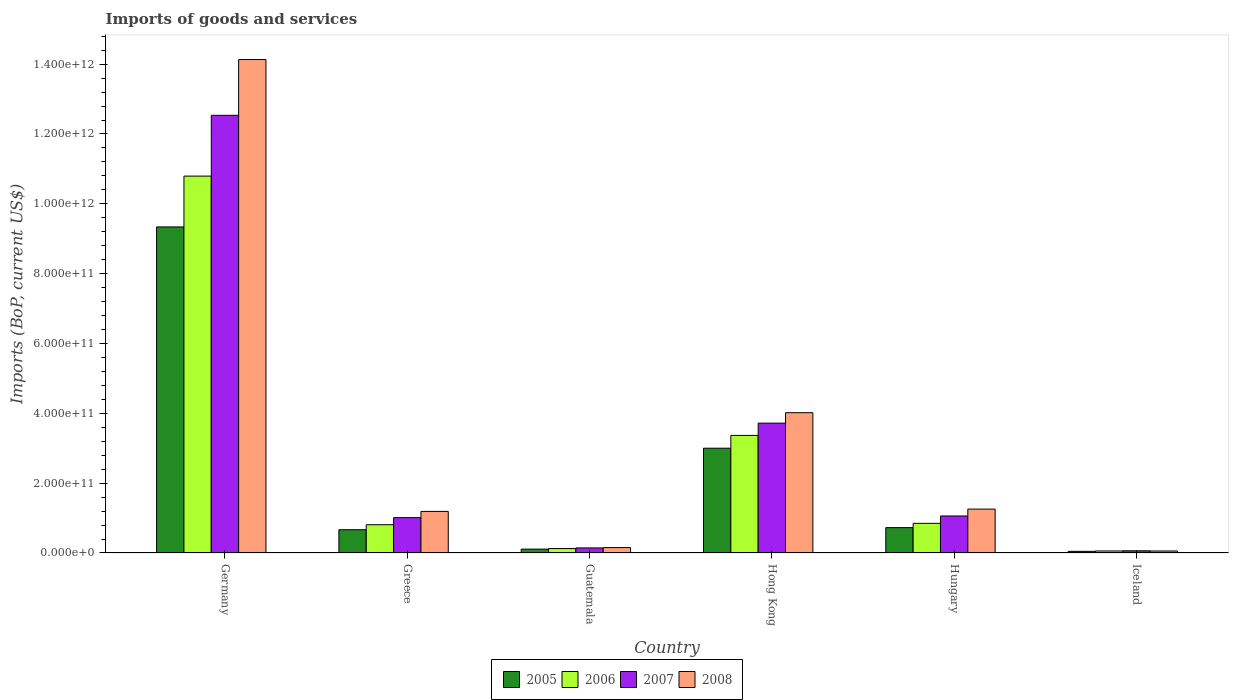How many different coloured bars are there?
Ensure brevity in your answer.  4. Are the number of bars per tick equal to the number of legend labels?
Make the answer very short. Yes. What is the label of the 5th group of bars from the left?
Provide a succinct answer. Hungary. In how many cases, is the number of bars for a given country not equal to the number of legend labels?
Make the answer very short. 0. What is the amount spent on imports in 2006 in Greece?
Your response must be concise. 8.09e+1. Across all countries, what is the maximum amount spent on imports in 2008?
Offer a very short reply. 1.41e+12. Across all countries, what is the minimum amount spent on imports in 2006?
Ensure brevity in your answer.  5.82e+09. What is the total amount spent on imports in 2006 in the graph?
Your answer should be very brief. 1.60e+12. What is the difference between the amount spent on imports in 2008 in Hong Kong and that in Hungary?
Make the answer very short. 2.76e+11. What is the difference between the amount spent on imports in 2008 in Guatemala and the amount spent on imports in 2006 in Hong Kong?
Your answer should be very brief. -3.21e+11. What is the average amount spent on imports in 2008 per country?
Provide a succinct answer. 3.47e+11. What is the difference between the amount spent on imports of/in 2005 and amount spent on imports of/in 2008 in Hong Kong?
Your answer should be compact. -1.02e+11. What is the ratio of the amount spent on imports in 2005 in Guatemala to that in Iceland?
Offer a terse response. 2.37. Is the difference between the amount spent on imports in 2005 in Hong Kong and Iceland greater than the difference between the amount spent on imports in 2008 in Hong Kong and Iceland?
Your answer should be very brief. No. What is the difference between the highest and the second highest amount spent on imports in 2007?
Your answer should be compact. 1.15e+12. What is the difference between the highest and the lowest amount spent on imports in 2005?
Ensure brevity in your answer.  9.29e+11. In how many countries, is the amount spent on imports in 2008 greater than the average amount spent on imports in 2008 taken over all countries?
Provide a short and direct response. 2. Is the sum of the amount spent on imports in 2007 in Germany and Guatemala greater than the maximum amount spent on imports in 2008 across all countries?
Ensure brevity in your answer.  No. Is it the case that in every country, the sum of the amount spent on imports in 2008 and amount spent on imports in 2006 is greater than the sum of amount spent on imports in 2007 and amount spent on imports in 2005?
Keep it short and to the point. No. Is it the case that in every country, the sum of the amount spent on imports in 2005 and amount spent on imports in 2008 is greater than the amount spent on imports in 2007?
Offer a terse response. Yes. How many countries are there in the graph?
Make the answer very short. 6. What is the difference between two consecutive major ticks on the Y-axis?
Your response must be concise. 2.00e+11. Where does the legend appear in the graph?
Keep it short and to the point. Bottom center. How many legend labels are there?
Give a very brief answer. 4. How are the legend labels stacked?
Your answer should be compact. Horizontal. What is the title of the graph?
Offer a very short reply. Imports of goods and services. Does "1982" appear as one of the legend labels in the graph?
Give a very brief answer. No. What is the label or title of the Y-axis?
Your response must be concise. Imports (BoP, current US$). What is the Imports (BoP, current US$) of 2005 in Germany?
Ensure brevity in your answer.  9.34e+11. What is the Imports (BoP, current US$) in 2006 in Germany?
Provide a short and direct response. 1.08e+12. What is the Imports (BoP, current US$) in 2007 in Germany?
Offer a terse response. 1.25e+12. What is the Imports (BoP, current US$) of 2008 in Germany?
Provide a short and direct response. 1.41e+12. What is the Imports (BoP, current US$) of 2005 in Greece?
Offer a very short reply. 6.66e+1. What is the Imports (BoP, current US$) of 2006 in Greece?
Give a very brief answer. 8.09e+1. What is the Imports (BoP, current US$) of 2007 in Greece?
Offer a terse response. 1.01e+11. What is the Imports (BoP, current US$) in 2008 in Greece?
Keep it short and to the point. 1.19e+11. What is the Imports (BoP, current US$) of 2005 in Guatemala?
Ensure brevity in your answer.  1.11e+1. What is the Imports (BoP, current US$) in 2006 in Guatemala?
Your response must be concise. 1.27e+1. What is the Imports (BoP, current US$) of 2007 in Guatemala?
Your response must be concise. 1.45e+1. What is the Imports (BoP, current US$) of 2008 in Guatemala?
Ensure brevity in your answer.  1.55e+1. What is the Imports (BoP, current US$) of 2005 in Hong Kong?
Offer a very short reply. 3.00e+11. What is the Imports (BoP, current US$) of 2006 in Hong Kong?
Your response must be concise. 3.37e+11. What is the Imports (BoP, current US$) of 2007 in Hong Kong?
Provide a succinct answer. 3.72e+11. What is the Imports (BoP, current US$) in 2008 in Hong Kong?
Provide a short and direct response. 4.02e+11. What is the Imports (BoP, current US$) of 2005 in Hungary?
Your answer should be very brief. 7.26e+1. What is the Imports (BoP, current US$) in 2006 in Hungary?
Your answer should be very brief. 8.49e+1. What is the Imports (BoP, current US$) in 2007 in Hungary?
Your response must be concise. 1.06e+11. What is the Imports (BoP, current US$) of 2008 in Hungary?
Your answer should be compact. 1.26e+11. What is the Imports (BoP, current US$) of 2005 in Iceland?
Your answer should be very brief. 4.68e+09. What is the Imports (BoP, current US$) in 2006 in Iceland?
Provide a succinct answer. 5.82e+09. What is the Imports (BoP, current US$) in 2007 in Iceland?
Give a very brief answer. 6.27e+09. What is the Imports (BoP, current US$) in 2008 in Iceland?
Your answer should be compact. 5.71e+09. Across all countries, what is the maximum Imports (BoP, current US$) in 2005?
Provide a succinct answer. 9.34e+11. Across all countries, what is the maximum Imports (BoP, current US$) of 2006?
Make the answer very short. 1.08e+12. Across all countries, what is the maximum Imports (BoP, current US$) in 2007?
Your answer should be compact. 1.25e+12. Across all countries, what is the maximum Imports (BoP, current US$) of 2008?
Offer a very short reply. 1.41e+12. Across all countries, what is the minimum Imports (BoP, current US$) in 2005?
Ensure brevity in your answer.  4.68e+09. Across all countries, what is the minimum Imports (BoP, current US$) in 2006?
Provide a short and direct response. 5.82e+09. Across all countries, what is the minimum Imports (BoP, current US$) in 2007?
Your answer should be very brief. 6.27e+09. Across all countries, what is the minimum Imports (BoP, current US$) of 2008?
Ensure brevity in your answer.  5.71e+09. What is the total Imports (BoP, current US$) in 2005 in the graph?
Offer a terse response. 1.39e+12. What is the total Imports (BoP, current US$) of 2006 in the graph?
Your response must be concise. 1.60e+12. What is the total Imports (BoP, current US$) of 2007 in the graph?
Make the answer very short. 1.85e+12. What is the total Imports (BoP, current US$) in 2008 in the graph?
Provide a short and direct response. 2.08e+12. What is the difference between the Imports (BoP, current US$) in 2005 in Germany and that in Greece?
Make the answer very short. 8.67e+11. What is the difference between the Imports (BoP, current US$) in 2006 in Germany and that in Greece?
Your answer should be very brief. 9.98e+11. What is the difference between the Imports (BoP, current US$) of 2007 in Germany and that in Greece?
Your answer should be very brief. 1.15e+12. What is the difference between the Imports (BoP, current US$) of 2008 in Germany and that in Greece?
Make the answer very short. 1.29e+12. What is the difference between the Imports (BoP, current US$) in 2005 in Germany and that in Guatemala?
Make the answer very short. 9.23e+11. What is the difference between the Imports (BoP, current US$) of 2006 in Germany and that in Guatemala?
Ensure brevity in your answer.  1.07e+12. What is the difference between the Imports (BoP, current US$) of 2007 in Germany and that in Guatemala?
Give a very brief answer. 1.24e+12. What is the difference between the Imports (BoP, current US$) in 2008 in Germany and that in Guatemala?
Your response must be concise. 1.40e+12. What is the difference between the Imports (BoP, current US$) of 2005 in Germany and that in Hong Kong?
Give a very brief answer. 6.34e+11. What is the difference between the Imports (BoP, current US$) in 2006 in Germany and that in Hong Kong?
Offer a very short reply. 7.43e+11. What is the difference between the Imports (BoP, current US$) in 2007 in Germany and that in Hong Kong?
Make the answer very short. 8.82e+11. What is the difference between the Imports (BoP, current US$) of 2008 in Germany and that in Hong Kong?
Your answer should be compact. 1.01e+12. What is the difference between the Imports (BoP, current US$) of 2005 in Germany and that in Hungary?
Your answer should be very brief. 8.61e+11. What is the difference between the Imports (BoP, current US$) of 2006 in Germany and that in Hungary?
Offer a very short reply. 9.95e+11. What is the difference between the Imports (BoP, current US$) of 2007 in Germany and that in Hungary?
Offer a very short reply. 1.15e+12. What is the difference between the Imports (BoP, current US$) in 2008 in Germany and that in Hungary?
Your response must be concise. 1.29e+12. What is the difference between the Imports (BoP, current US$) in 2005 in Germany and that in Iceland?
Ensure brevity in your answer.  9.29e+11. What is the difference between the Imports (BoP, current US$) in 2006 in Germany and that in Iceland?
Keep it short and to the point. 1.07e+12. What is the difference between the Imports (BoP, current US$) in 2007 in Germany and that in Iceland?
Keep it short and to the point. 1.25e+12. What is the difference between the Imports (BoP, current US$) of 2008 in Germany and that in Iceland?
Give a very brief answer. 1.41e+12. What is the difference between the Imports (BoP, current US$) in 2005 in Greece and that in Guatemala?
Your answer should be compact. 5.55e+1. What is the difference between the Imports (BoP, current US$) of 2006 in Greece and that in Guatemala?
Keep it short and to the point. 6.82e+1. What is the difference between the Imports (BoP, current US$) of 2007 in Greece and that in Guatemala?
Provide a short and direct response. 8.68e+1. What is the difference between the Imports (BoP, current US$) of 2008 in Greece and that in Guatemala?
Offer a terse response. 1.04e+11. What is the difference between the Imports (BoP, current US$) in 2005 in Greece and that in Hong Kong?
Make the answer very short. -2.33e+11. What is the difference between the Imports (BoP, current US$) of 2006 in Greece and that in Hong Kong?
Provide a short and direct response. -2.56e+11. What is the difference between the Imports (BoP, current US$) of 2007 in Greece and that in Hong Kong?
Offer a very short reply. -2.71e+11. What is the difference between the Imports (BoP, current US$) in 2008 in Greece and that in Hong Kong?
Offer a very short reply. -2.83e+11. What is the difference between the Imports (BoP, current US$) of 2005 in Greece and that in Hungary?
Your response must be concise. -6.02e+09. What is the difference between the Imports (BoP, current US$) in 2006 in Greece and that in Hungary?
Provide a short and direct response. -3.99e+09. What is the difference between the Imports (BoP, current US$) in 2007 in Greece and that in Hungary?
Make the answer very short. -4.71e+09. What is the difference between the Imports (BoP, current US$) in 2008 in Greece and that in Hungary?
Your answer should be compact. -6.66e+09. What is the difference between the Imports (BoP, current US$) of 2005 in Greece and that in Iceland?
Keep it short and to the point. 6.19e+1. What is the difference between the Imports (BoP, current US$) in 2006 in Greece and that in Iceland?
Provide a short and direct response. 7.51e+1. What is the difference between the Imports (BoP, current US$) in 2007 in Greece and that in Iceland?
Provide a short and direct response. 9.50e+1. What is the difference between the Imports (BoP, current US$) of 2008 in Greece and that in Iceland?
Offer a very short reply. 1.13e+11. What is the difference between the Imports (BoP, current US$) in 2005 in Guatemala and that in Hong Kong?
Give a very brief answer. -2.89e+11. What is the difference between the Imports (BoP, current US$) in 2006 in Guatemala and that in Hong Kong?
Ensure brevity in your answer.  -3.24e+11. What is the difference between the Imports (BoP, current US$) in 2007 in Guatemala and that in Hong Kong?
Ensure brevity in your answer.  -3.57e+11. What is the difference between the Imports (BoP, current US$) of 2008 in Guatemala and that in Hong Kong?
Ensure brevity in your answer.  -3.86e+11. What is the difference between the Imports (BoP, current US$) in 2005 in Guatemala and that in Hungary?
Ensure brevity in your answer.  -6.15e+1. What is the difference between the Imports (BoP, current US$) in 2006 in Guatemala and that in Hungary?
Ensure brevity in your answer.  -7.22e+1. What is the difference between the Imports (BoP, current US$) of 2007 in Guatemala and that in Hungary?
Your answer should be very brief. -9.15e+1. What is the difference between the Imports (BoP, current US$) of 2008 in Guatemala and that in Hungary?
Ensure brevity in your answer.  -1.10e+11. What is the difference between the Imports (BoP, current US$) in 2005 in Guatemala and that in Iceland?
Give a very brief answer. 6.42e+09. What is the difference between the Imports (BoP, current US$) in 2006 in Guatemala and that in Iceland?
Give a very brief answer. 6.90e+09. What is the difference between the Imports (BoP, current US$) in 2007 in Guatemala and that in Iceland?
Ensure brevity in your answer.  8.24e+09. What is the difference between the Imports (BoP, current US$) of 2008 in Guatemala and that in Iceland?
Keep it short and to the point. 9.75e+09. What is the difference between the Imports (BoP, current US$) of 2005 in Hong Kong and that in Hungary?
Keep it short and to the point. 2.27e+11. What is the difference between the Imports (BoP, current US$) in 2006 in Hong Kong and that in Hungary?
Your answer should be compact. 2.52e+11. What is the difference between the Imports (BoP, current US$) in 2007 in Hong Kong and that in Hungary?
Offer a terse response. 2.66e+11. What is the difference between the Imports (BoP, current US$) of 2008 in Hong Kong and that in Hungary?
Ensure brevity in your answer.  2.76e+11. What is the difference between the Imports (BoP, current US$) in 2005 in Hong Kong and that in Iceland?
Ensure brevity in your answer.  2.95e+11. What is the difference between the Imports (BoP, current US$) of 2006 in Hong Kong and that in Iceland?
Provide a succinct answer. 3.31e+11. What is the difference between the Imports (BoP, current US$) of 2007 in Hong Kong and that in Iceland?
Your response must be concise. 3.66e+11. What is the difference between the Imports (BoP, current US$) in 2008 in Hong Kong and that in Iceland?
Offer a very short reply. 3.96e+11. What is the difference between the Imports (BoP, current US$) of 2005 in Hungary and that in Iceland?
Your answer should be compact. 6.80e+1. What is the difference between the Imports (BoP, current US$) in 2006 in Hungary and that in Iceland?
Your answer should be compact. 7.91e+1. What is the difference between the Imports (BoP, current US$) in 2007 in Hungary and that in Iceland?
Provide a succinct answer. 9.97e+1. What is the difference between the Imports (BoP, current US$) in 2008 in Hungary and that in Iceland?
Make the answer very short. 1.20e+11. What is the difference between the Imports (BoP, current US$) in 2005 in Germany and the Imports (BoP, current US$) in 2006 in Greece?
Ensure brevity in your answer.  8.53e+11. What is the difference between the Imports (BoP, current US$) in 2005 in Germany and the Imports (BoP, current US$) in 2007 in Greece?
Your answer should be very brief. 8.33e+11. What is the difference between the Imports (BoP, current US$) of 2005 in Germany and the Imports (BoP, current US$) of 2008 in Greece?
Provide a short and direct response. 8.15e+11. What is the difference between the Imports (BoP, current US$) of 2006 in Germany and the Imports (BoP, current US$) of 2007 in Greece?
Offer a terse response. 9.78e+11. What is the difference between the Imports (BoP, current US$) in 2006 in Germany and the Imports (BoP, current US$) in 2008 in Greece?
Ensure brevity in your answer.  9.60e+11. What is the difference between the Imports (BoP, current US$) of 2007 in Germany and the Imports (BoP, current US$) of 2008 in Greece?
Give a very brief answer. 1.13e+12. What is the difference between the Imports (BoP, current US$) in 2005 in Germany and the Imports (BoP, current US$) in 2006 in Guatemala?
Offer a terse response. 9.21e+11. What is the difference between the Imports (BoP, current US$) of 2005 in Germany and the Imports (BoP, current US$) of 2007 in Guatemala?
Give a very brief answer. 9.19e+11. What is the difference between the Imports (BoP, current US$) in 2005 in Germany and the Imports (BoP, current US$) in 2008 in Guatemala?
Offer a very short reply. 9.18e+11. What is the difference between the Imports (BoP, current US$) in 2006 in Germany and the Imports (BoP, current US$) in 2007 in Guatemala?
Provide a succinct answer. 1.06e+12. What is the difference between the Imports (BoP, current US$) in 2006 in Germany and the Imports (BoP, current US$) in 2008 in Guatemala?
Your answer should be compact. 1.06e+12. What is the difference between the Imports (BoP, current US$) of 2007 in Germany and the Imports (BoP, current US$) of 2008 in Guatemala?
Offer a terse response. 1.24e+12. What is the difference between the Imports (BoP, current US$) in 2005 in Germany and the Imports (BoP, current US$) in 2006 in Hong Kong?
Your answer should be compact. 5.97e+11. What is the difference between the Imports (BoP, current US$) in 2005 in Germany and the Imports (BoP, current US$) in 2007 in Hong Kong?
Offer a very short reply. 5.62e+11. What is the difference between the Imports (BoP, current US$) of 2005 in Germany and the Imports (BoP, current US$) of 2008 in Hong Kong?
Your answer should be compact. 5.32e+11. What is the difference between the Imports (BoP, current US$) of 2006 in Germany and the Imports (BoP, current US$) of 2007 in Hong Kong?
Offer a very short reply. 7.08e+11. What is the difference between the Imports (BoP, current US$) of 2006 in Germany and the Imports (BoP, current US$) of 2008 in Hong Kong?
Offer a terse response. 6.78e+11. What is the difference between the Imports (BoP, current US$) of 2007 in Germany and the Imports (BoP, current US$) of 2008 in Hong Kong?
Offer a very short reply. 8.52e+11. What is the difference between the Imports (BoP, current US$) of 2005 in Germany and the Imports (BoP, current US$) of 2006 in Hungary?
Make the answer very short. 8.49e+11. What is the difference between the Imports (BoP, current US$) of 2005 in Germany and the Imports (BoP, current US$) of 2007 in Hungary?
Your answer should be compact. 8.28e+11. What is the difference between the Imports (BoP, current US$) of 2005 in Germany and the Imports (BoP, current US$) of 2008 in Hungary?
Provide a succinct answer. 8.08e+11. What is the difference between the Imports (BoP, current US$) of 2006 in Germany and the Imports (BoP, current US$) of 2007 in Hungary?
Your answer should be compact. 9.73e+11. What is the difference between the Imports (BoP, current US$) in 2006 in Germany and the Imports (BoP, current US$) in 2008 in Hungary?
Provide a succinct answer. 9.54e+11. What is the difference between the Imports (BoP, current US$) in 2007 in Germany and the Imports (BoP, current US$) in 2008 in Hungary?
Your answer should be compact. 1.13e+12. What is the difference between the Imports (BoP, current US$) of 2005 in Germany and the Imports (BoP, current US$) of 2006 in Iceland?
Give a very brief answer. 9.28e+11. What is the difference between the Imports (BoP, current US$) in 2005 in Germany and the Imports (BoP, current US$) in 2007 in Iceland?
Your response must be concise. 9.28e+11. What is the difference between the Imports (BoP, current US$) of 2005 in Germany and the Imports (BoP, current US$) of 2008 in Iceland?
Keep it short and to the point. 9.28e+11. What is the difference between the Imports (BoP, current US$) in 2006 in Germany and the Imports (BoP, current US$) in 2007 in Iceland?
Your answer should be very brief. 1.07e+12. What is the difference between the Imports (BoP, current US$) of 2006 in Germany and the Imports (BoP, current US$) of 2008 in Iceland?
Your response must be concise. 1.07e+12. What is the difference between the Imports (BoP, current US$) in 2007 in Germany and the Imports (BoP, current US$) in 2008 in Iceland?
Give a very brief answer. 1.25e+12. What is the difference between the Imports (BoP, current US$) in 2005 in Greece and the Imports (BoP, current US$) in 2006 in Guatemala?
Keep it short and to the point. 5.39e+1. What is the difference between the Imports (BoP, current US$) in 2005 in Greece and the Imports (BoP, current US$) in 2007 in Guatemala?
Your response must be concise. 5.21e+1. What is the difference between the Imports (BoP, current US$) in 2005 in Greece and the Imports (BoP, current US$) in 2008 in Guatemala?
Give a very brief answer. 5.12e+1. What is the difference between the Imports (BoP, current US$) of 2006 in Greece and the Imports (BoP, current US$) of 2007 in Guatemala?
Keep it short and to the point. 6.64e+1. What is the difference between the Imports (BoP, current US$) of 2006 in Greece and the Imports (BoP, current US$) of 2008 in Guatemala?
Your answer should be compact. 6.55e+1. What is the difference between the Imports (BoP, current US$) of 2007 in Greece and the Imports (BoP, current US$) of 2008 in Guatemala?
Your answer should be compact. 8.58e+1. What is the difference between the Imports (BoP, current US$) in 2005 in Greece and the Imports (BoP, current US$) in 2006 in Hong Kong?
Your response must be concise. -2.70e+11. What is the difference between the Imports (BoP, current US$) in 2005 in Greece and the Imports (BoP, current US$) in 2007 in Hong Kong?
Your answer should be compact. -3.05e+11. What is the difference between the Imports (BoP, current US$) of 2005 in Greece and the Imports (BoP, current US$) of 2008 in Hong Kong?
Give a very brief answer. -3.35e+11. What is the difference between the Imports (BoP, current US$) of 2006 in Greece and the Imports (BoP, current US$) of 2007 in Hong Kong?
Provide a short and direct response. -2.91e+11. What is the difference between the Imports (BoP, current US$) in 2006 in Greece and the Imports (BoP, current US$) in 2008 in Hong Kong?
Keep it short and to the point. -3.21e+11. What is the difference between the Imports (BoP, current US$) in 2007 in Greece and the Imports (BoP, current US$) in 2008 in Hong Kong?
Offer a terse response. -3.01e+11. What is the difference between the Imports (BoP, current US$) of 2005 in Greece and the Imports (BoP, current US$) of 2006 in Hungary?
Your answer should be very brief. -1.83e+1. What is the difference between the Imports (BoP, current US$) in 2005 in Greece and the Imports (BoP, current US$) in 2007 in Hungary?
Keep it short and to the point. -3.94e+1. What is the difference between the Imports (BoP, current US$) in 2005 in Greece and the Imports (BoP, current US$) in 2008 in Hungary?
Your answer should be compact. -5.91e+1. What is the difference between the Imports (BoP, current US$) of 2006 in Greece and the Imports (BoP, current US$) of 2007 in Hungary?
Ensure brevity in your answer.  -2.51e+1. What is the difference between the Imports (BoP, current US$) of 2006 in Greece and the Imports (BoP, current US$) of 2008 in Hungary?
Provide a succinct answer. -4.48e+1. What is the difference between the Imports (BoP, current US$) in 2007 in Greece and the Imports (BoP, current US$) in 2008 in Hungary?
Ensure brevity in your answer.  -2.44e+1. What is the difference between the Imports (BoP, current US$) in 2005 in Greece and the Imports (BoP, current US$) in 2006 in Iceland?
Your answer should be very brief. 6.08e+1. What is the difference between the Imports (BoP, current US$) of 2005 in Greece and the Imports (BoP, current US$) of 2007 in Iceland?
Provide a short and direct response. 6.03e+1. What is the difference between the Imports (BoP, current US$) in 2005 in Greece and the Imports (BoP, current US$) in 2008 in Iceland?
Your answer should be very brief. 6.09e+1. What is the difference between the Imports (BoP, current US$) in 2006 in Greece and the Imports (BoP, current US$) in 2007 in Iceland?
Your response must be concise. 7.47e+1. What is the difference between the Imports (BoP, current US$) of 2006 in Greece and the Imports (BoP, current US$) of 2008 in Iceland?
Offer a very short reply. 7.52e+1. What is the difference between the Imports (BoP, current US$) of 2007 in Greece and the Imports (BoP, current US$) of 2008 in Iceland?
Make the answer very short. 9.56e+1. What is the difference between the Imports (BoP, current US$) in 2005 in Guatemala and the Imports (BoP, current US$) in 2006 in Hong Kong?
Offer a very short reply. -3.26e+11. What is the difference between the Imports (BoP, current US$) of 2005 in Guatemala and the Imports (BoP, current US$) of 2007 in Hong Kong?
Provide a succinct answer. -3.61e+11. What is the difference between the Imports (BoP, current US$) of 2005 in Guatemala and the Imports (BoP, current US$) of 2008 in Hong Kong?
Your response must be concise. -3.91e+11. What is the difference between the Imports (BoP, current US$) of 2006 in Guatemala and the Imports (BoP, current US$) of 2007 in Hong Kong?
Your answer should be very brief. -3.59e+11. What is the difference between the Imports (BoP, current US$) of 2006 in Guatemala and the Imports (BoP, current US$) of 2008 in Hong Kong?
Provide a short and direct response. -3.89e+11. What is the difference between the Imports (BoP, current US$) in 2007 in Guatemala and the Imports (BoP, current US$) in 2008 in Hong Kong?
Your answer should be very brief. -3.87e+11. What is the difference between the Imports (BoP, current US$) of 2005 in Guatemala and the Imports (BoP, current US$) of 2006 in Hungary?
Provide a succinct answer. -7.38e+1. What is the difference between the Imports (BoP, current US$) in 2005 in Guatemala and the Imports (BoP, current US$) in 2007 in Hungary?
Your answer should be very brief. -9.49e+1. What is the difference between the Imports (BoP, current US$) of 2005 in Guatemala and the Imports (BoP, current US$) of 2008 in Hungary?
Your answer should be compact. -1.15e+11. What is the difference between the Imports (BoP, current US$) of 2006 in Guatemala and the Imports (BoP, current US$) of 2007 in Hungary?
Your response must be concise. -9.33e+1. What is the difference between the Imports (BoP, current US$) of 2006 in Guatemala and the Imports (BoP, current US$) of 2008 in Hungary?
Your answer should be compact. -1.13e+11. What is the difference between the Imports (BoP, current US$) of 2007 in Guatemala and the Imports (BoP, current US$) of 2008 in Hungary?
Your response must be concise. -1.11e+11. What is the difference between the Imports (BoP, current US$) in 2005 in Guatemala and the Imports (BoP, current US$) in 2006 in Iceland?
Offer a very short reply. 5.28e+09. What is the difference between the Imports (BoP, current US$) in 2005 in Guatemala and the Imports (BoP, current US$) in 2007 in Iceland?
Offer a terse response. 4.83e+09. What is the difference between the Imports (BoP, current US$) in 2005 in Guatemala and the Imports (BoP, current US$) in 2008 in Iceland?
Provide a succinct answer. 5.39e+09. What is the difference between the Imports (BoP, current US$) of 2006 in Guatemala and the Imports (BoP, current US$) of 2007 in Iceland?
Provide a succinct answer. 6.44e+09. What is the difference between the Imports (BoP, current US$) of 2006 in Guatemala and the Imports (BoP, current US$) of 2008 in Iceland?
Give a very brief answer. 7.00e+09. What is the difference between the Imports (BoP, current US$) of 2007 in Guatemala and the Imports (BoP, current US$) of 2008 in Iceland?
Ensure brevity in your answer.  8.80e+09. What is the difference between the Imports (BoP, current US$) in 2005 in Hong Kong and the Imports (BoP, current US$) in 2006 in Hungary?
Make the answer very short. 2.15e+11. What is the difference between the Imports (BoP, current US$) of 2005 in Hong Kong and the Imports (BoP, current US$) of 2007 in Hungary?
Your answer should be very brief. 1.94e+11. What is the difference between the Imports (BoP, current US$) in 2005 in Hong Kong and the Imports (BoP, current US$) in 2008 in Hungary?
Ensure brevity in your answer.  1.74e+11. What is the difference between the Imports (BoP, current US$) of 2006 in Hong Kong and the Imports (BoP, current US$) of 2007 in Hungary?
Provide a short and direct response. 2.31e+11. What is the difference between the Imports (BoP, current US$) in 2006 in Hong Kong and the Imports (BoP, current US$) in 2008 in Hungary?
Your answer should be compact. 2.11e+11. What is the difference between the Imports (BoP, current US$) in 2007 in Hong Kong and the Imports (BoP, current US$) in 2008 in Hungary?
Provide a short and direct response. 2.46e+11. What is the difference between the Imports (BoP, current US$) in 2005 in Hong Kong and the Imports (BoP, current US$) in 2006 in Iceland?
Make the answer very short. 2.94e+11. What is the difference between the Imports (BoP, current US$) of 2005 in Hong Kong and the Imports (BoP, current US$) of 2007 in Iceland?
Your answer should be compact. 2.94e+11. What is the difference between the Imports (BoP, current US$) in 2005 in Hong Kong and the Imports (BoP, current US$) in 2008 in Iceland?
Your answer should be compact. 2.94e+11. What is the difference between the Imports (BoP, current US$) in 2006 in Hong Kong and the Imports (BoP, current US$) in 2007 in Iceland?
Provide a short and direct response. 3.30e+11. What is the difference between the Imports (BoP, current US$) of 2006 in Hong Kong and the Imports (BoP, current US$) of 2008 in Iceland?
Ensure brevity in your answer.  3.31e+11. What is the difference between the Imports (BoP, current US$) in 2007 in Hong Kong and the Imports (BoP, current US$) in 2008 in Iceland?
Your answer should be compact. 3.66e+11. What is the difference between the Imports (BoP, current US$) in 2005 in Hungary and the Imports (BoP, current US$) in 2006 in Iceland?
Your answer should be compact. 6.68e+1. What is the difference between the Imports (BoP, current US$) in 2005 in Hungary and the Imports (BoP, current US$) in 2007 in Iceland?
Make the answer very short. 6.64e+1. What is the difference between the Imports (BoP, current US$) of 2005 in Hungary and the Imports (BoP, current US$) of 2008 in Iceland?
Your response must be concise. 6.69e+1. What is the difference between the Imports (BoP, current US$) of 2006 in Hungary and the Imports (BoP, current US$) of 2007 in Iceland?
Your answer should be very brief. 7.86e+1. What is the difference between the Imports (BoP, current US$) of 2006 in Hungary and the Imports (BoP, current US$) of 2008 in Iceland?
Provide a succinct answer. 7.92e+1. What is the difference between the Imports (BoP, current US$) of 2007 in Hungary and the Imports (BoP, current US$) of 2008 in Iceland?
Provide a short and direct response. 1.00e+11. What is the average Imports (BoP, current US$) of 2005 per country?
Your response must be concise. 2.31e+11. What is the average Imports (BoP, current US$) in 2006 per country?
Keep it short and to the point. 2.67e+11. What is the average Imports (BoP, current US$) of 2007 per country?
Offer a terse response. 3.09e+11. What is the average Imports (BoP, current US$) in 2008 per country?
Keep it short and to the point. 3.47e+11. What is the difference between the Imports (BoP, current US$) in 2005 and Imports (BoP, current US$) in 2006 in Germany?
Keep it short and to the point. -1.46e+11. What is the difference between the Imports (BoP, current US$) in 2005 and Imports (BoP, current US$) in 2007 in Germany?
Keep it short and to the point. -3.20e+11. What is the difference between the Imports (BoP, current US$) in 2005 and Imports (BoP, current US$) in 2008 in Germany?
Keep it short and to the point. -4.79e+11. What is the difference between the Imports (BoP, current US$) of 2006 and Imports (BoP, current US$) of 2007 in Germany?
Give a very brief answer. -1.74e+11. What is the difference between the Imports (BoP, current US$) in 2006 and Imports (BoP, current US$) in 2008 in Germany?
Provide a short and direct response. -3.34e+11. What is the difference between the Imports (BoP, current US$) in 2007 and Imports (BoP, current US$) in 2008 in Germany?
Provide a short and direct response. -1.60e+11. What is the difference between the Imports (BoP, current US$) in 2005 and Imports (BoP, current US$) in 2006 in Greece?
Offer a terse response. -1.43e+1. What is the difference between the Imports (BoP, current US$) of 2005 and Imports (BoP, current US$) of 2007 in Greece?
Make the answer very short. -3.47e+1. What is the difference between the Imports (BoP, current US$) of 2005 and Imports (BoP, current US$) of 2008 in Greece?
Ensure brevity in your answer.  -5.25e+1. What is the difference between the Imports (BoP, current US$) in 2006 and Imports (BoP, current US$) in 2007 in Greece?
Ensure brevity in your answer.  -2.04e+1. What is the difference between the Imports (BoP, current US$) of 2006 and Imports (BoP, current US$) of 2008 in Greece?
Provide a short and direct response. -3.81e+1. What is the difference between the Imports (BoP, current US$) in 2007 and Imports (BoP, current US$) in 2008 in Greece?
Ensure brevity in your answer.  -1.78e+1. What is the difference between the Imports (BoP, current US$) of 2005 and Imports (BoP, current US$) of 2006 in Guatemala?
Your answer should be very brief. -1.61e+09. What is the difference between the Imports (BoP, current US$) in 2005 and Imports (BoP, current US$) in 2007 in Guatemala?
Offer a very short reply. -3.41e+09. What is the difference between the Imports (BoP, current US$) in 2005 and Imports (BoP, current US$) in 2008 in Guatemala?
Offer a very short reply. -4.36e+09. What is the difference between the Imports (BoP, current US$) of 2006 and Imports (BoP, current US$) of 2007 in Guatemala?
Make the answer very short. -1.80e+09. What is the difference between the Imports (BoP, current US$) in 2006 and Imports (BoP, current US$) in 2008 in Guatemala?
Your answer should be very brief. -2.75e+09. What is the difference between the Imports (BoP, current US$) of 2007 and Imports (BoP, current US$) of 2008 in Guatemala?
Your response must be concise. -9.53e+08. What is the difference between the Imports (BoP, current US$) in 2005 and Imports (BoP, current US$) in 2006 in Hong Kong?
Provide a succinct answer. -3.67e+1. What is the difference between the Imports (BoP, current US$) in 2005 and Imports (BoP, current US$) in 2007 in Hong Kong?
Your answer should be compact. -7.18e+1. What is the difference between the Imports (BoP, current US$) in 2005 and Imports (BoP, current US$) in 2008 in Hong Kong?
Give a very brief answer. -1.02e+11. What is the difference between the Imports (BoP, current US$) in 2006 and Imports (BoP, current US$) in 2007 in Hong Kong?
Provide a short and direct response. -3.51e+1. What is the difference between the Imports (BoP, current US$) of 2006 and Imports (BoP, current US$) of 2008 in Hong Kong?
Your answer should be very brief. -6.50e+1. What is the difference between the Imports (BoP, current US$) of 2007 and Imports (BoP, current US$) of 2008 in Hong Kong?
Offer a very short reply. -2.99e+1. What is the difference between the Imports (BoP, current US$) in 2005 and Imports (BoP, current US$) in 2006 in Hungary?
Offer a very short reply. -1.23e+1. What is the difference between the Imports (BoP, current US$) of 2005 and Imports (BoP, current US$) of 2007 in Hungary?
Provide a short and direct response. -3.33e+1. What is the difference between the Imports (BoP, current US$) in 2005 and Imports (BoP, current US$) in 2008 in Hungary?
Your answer should be compact. -5.31e+1. What is the difference between the Imports (BoP, current US$) of 2006 and Imports (BoP, current US$) of 2007 in Hungary?
Ensure brevity in your answer.  -2.11e+1. What is the difference between the Imports (BoP, current US$) of 2006 and Imports (BoP, current US$) of 2008 in Hungary?
Keep it short and to the point. -4.08e+1. What is the difference between the Imports (BoP, current US$) in 2007 and Imports (BoP, current US$) in 2008 in Hungary?
Keep it short and to the point. -1.97e+1. What is the difference between the Imports (BoP, current US$) of 2005 and Imports (BoP, current US$) of 2006 in Iceland?
Offer a very short reply. -1.13e+09. What is the difference between the Imports (BoP, current US$) in 2005 and Imports (BoP, current US$) in 2007 in Iceland?
Your response must be concise. -1.59e+09. What is the difference between the Imports (BoP, current US$) in 2005 and Imports (BoP, current US$) in 2008 in Iceland?
Keep it short and to the point. -1.03e+09. What is the difference between the Imports (BoP, current US$) in 2006 and Imports (BoP, current US$) in 2007 in Iceland?
Keep it short and to the point. -4.53e+08. What is the difference between the Imports (BoP, current US$) in 2006 and Imports (BoP, current US$) in 2008 in Iceland?
Provide a short and direct response. 1.07e+08. What is the difference between the Imports (BoP, current US$) in 2007 and Imports (BoP, current US$) in 2008 in Iceland?
Make the answer very short. 5.60e+08. What is the ratio of the Imports (BoP, current US$) of 2005 in Germany to that in Greece?
Offer a terse response. 14.02. What is the ratio of the Imports (BoP, current US$) in 2006 in Germany to that in Greece?
Provide a short and direct response. 13.34. What is the ratio of the Imports (BoP, current US$) of 2007 in Germany to that in Greece?
Ensure brevity in your answer.  12.38. What is the ratio of the Imports (BoP, current US$) of 2008 in Germany to that in Greece?
Your response must be concise. 11.87. What is the ratio of the Imports (BoP, current US$) in 2005 in Germany to that in Guatemala?
Keep it short and to the point. 84.13. What is the ratio of the Imports (BoP, current US$) in 2006 in Germany to that in Guatemala?
Offer a terse response. 84.91. What is the ratio of the Imports (BoP, current US$) of 2007 in Germany to that in Guatemala?
Offer a very short reply. 86.38. What is the ratio of the Imports (BoP, current US$) in 2008 in Germany to that in Guatemala?
Offer a very short reply. 91.38. What is the ratio of the Imports (BoP, current US$) in 2005 in Germany to that in Hong Kong?
Your answer should be compact. 3.11. What is the ratio of the Imports (BoP, current US$) of 2006 in Germany to that in Hong Kong?
Your answer should be very brief. 3.21. What is the ratio of the Imports (BoP, current US$) of 2007 in Germany to that in Hong Kong?
Offer a terse response. 3.37. What is the ratio of the Imports (BoP, current US$) in 2008 in Germany to that in Hong Kong?
Give a very brief answer. 3.52. What is the ratio of the Imports (BoP, current US$) in 2005 in Germany to that in Hungary?
Keep it short and to the point. 12.86. What is the ratio of the Imports (BoP, current US$) in 2006 in Germany to that in Hungary?
Your answer should be very brief. 12.71. What is the ratio of the Imports (BoP, current US$) of 2007 in Germany to that in Hungary?
Offer a very short reply. 11.83. What is the ratio of the Imports (BoP, current US$) in 2008 in Germany to that in Hungary?
Ensure brevity in your answer.  11.24. What is the ratio of the Imports (BoP, current US$) in 2005 in Germany to that in Iceland?
Your answer should be compact. 199.47. What is the ratio of the Imports (BoP, current US$) in 2006 in Germany to that in Iceland?
Ensure brevity in your answer.  185.59. What is the ratio of the Imports (BoP, current US$) of 2007 in Germany to that in Iceland?
Ensure brevity in your answer.  199.93. What is the ratio of the Imports (BoP, current US$) of 2008 in Germany to that in Iceland?
Offer a very short reply. 247.52. What is the ratio of the Imports (BoP, current US$) of 2005 in Greece to that in Guatemala?
Provide a succinct answer. 6. What is the ratio of the Imports (BoP, current US$) of 2006 in Greece to that in Guatemala?
Your answer should be compact. 6.37. What is the ratio of the Imports (BoP, current US$) of 2007 in Greece to that in Guatemala?
Your answer should be very brief. 6.98. What is the ratio of the Imports (BoP, current US$) of 2008 in Greece to that in Guatemala?
Keep it short and to the point. 7.7. What is the ratio of the Imports (BoP, current US$) in 2005 in Greece to that in Hong Kong?
Make the answer very short. 0.22. What is the ratio of the Imports (BoP, current US$) of 2006 in Greece to that in Hong Kong?
Give a very brief answer. 0.24. What is the ratio of the Imports (BoP, current US$) of 2007 in Greece to that in Hong Kong?
Your answer should be compact. 0.27. What is the ratio of the Imports (BoP, current US$) of 2008 in Greece to that in Hong Kong?
Offer a very short reply. 0.3. What is the ratio of the Imports (BoP, current US$) in 2005 in Greece to that in Hungary?
Give a very brief answer. 0.92. What is the ratio of the Imports (BoP, current US$) of 2006 in Greece to that in Hungary?
Your response must be concise. 0.95. What is the ratio of the Imports (BoP, current US$) in 2007 in Greece to that in Hungary?
Provide a succinct answer. 0.96. What is the ratio of the Imports (BoP, current US$) of 2008 in Greece to that in Hungary?
Offer a terse response. 0.95. What is the ratio of the Imports (BoP, current US$) of 2005 in Greece to that in Iceland?
Offer a terse response. 14.23. What is the ratio of the Imports (BoP, current US$) of 2006 in Greece to that in Iceland?
Offer a very short reply. 13.91. What is the ratio of the Imports (BoP, current US$) of 2007 in Greece to that in Iceland?
Keep it short and to the point. 16.15. What is the ratio of the Imports (BoP, current US$) in 2008 in Greece to that in Iceland?
Ensure brevity in your answer.  20.85. What is the ratio of the Imports (BoP, current US$) of 2005 in Guatemala to that in Hong Kong?
Keep it short and to the point. 0.04. What is the ratio of the Imports (BoP, current US$) of 2006 in Guatemala to that in Hong Kong?
Keep it short and to the point. 0.04. What is the ratio of the Imports (BoP, current US$) in 2007 in Guatemala to that in Hong Kong?
Your response must be concise. 0.04. What is the ratio of the Imports (BoP, current US$) in 2008 in Guatemala to that in Hong Kong?
Provide a succinct answer. 0.04. What is the ratio of the Imports (BoP, current US$) in 2005 in Guatemala to that in Hungary?
Provide a succinct answer. 0.15. What is the ratio of the Imports (BoP, current US$) in 2006 in Guatemala to that in Hungary?
Ensure brevity in your answer.  0.15. What is the ratio of the Imports (BoP, current US$) in 2007 in Guatemala to that in Hungary?
Your answer should be compact. 0.14. What is the ratio of the Imports (BoP, current US$) of 2008 in Guatemala to that in Hungary?
Ensure brevity in your answer.  0.12. What is the ratio of the Imports (BoP, current US$) of 2005 in Guatemala to that in Iceland?
Keep it short and to the point. 2.37. What is the ratio of the Imports (BoP, current US$) of 2006 in Guatemala to that in Iceland?
Provide a succinct answer. 2.19. What is the ratio of the Imports (BoP, current US$) in 2007 in Guatemala to that in Iceland?
Your response must be concise. 2.31. What is the ratio of the Imports (BoP, current US$) in 2008 in Guatemala to that in Iceland?
Give a very brief answer. 2.71. What is the ratio of the Imports (BoP, current US$) of 2005 in Hong Kong to that in Hungary?
Your response must be concise. 4.13. What is the ratio of the Imports (BoP, current US$) of 2006 in Hong Kong to that in Hungary?
Offer a terse response. 3.97. What is the ratio of the Imports (BoP, current US$) of 2007 in Hong Kong to that in Hungary?
Your answer should be compact. 3.51. What is the ratio of the Imports (BoP, current US$) of 2008 in Hong Kong to that in Hungary?
Your answer should be very brief. 3.2. What is the ratio of the Imports (BoP, current US$) of 2005 in Hong Kong to that in Iceland?
Your response must be concise. 64.09. What is the ratio of the Imports (BoP, current US$) in 2006 in Hong Kong to that in Iceland?
Offer a terse response. 57.9. What is the ratio of the Imports (BoP, current US$) of 2007 in Hong Kong to that in Iceland?
Your answer should be compact. 59.32. What is the ratio of the Imports (BoP, current US$) of 2008 in Hong Kong to that in Iceland?
Offer a very short reply. 70.37. What is the ratio of the Imports (BoP, current US$) of 2005 in Hungary to that in Iceland?
Give a very brief answer. 15.52. What is the ratio of the Imports (BoP, current US$) in 2006 in Hungary to that in Iceland?
Make the answer very short. 14.6. What is the ratio of the Imports (BoP, current US$) of 2007 in Hungary to that in Iceland?
Your answer should be compact. 16.91. What is the ratio of the Imports (BoP, current US$) in 2008 in Hungary to that in Iceland?
Your answer should be compact. 22.02. What is the difference between the highest and the second highest Imports (BoP, current US$) in 2005?
Your response must be concise. 6.34e+11. What is the difference between the highest and the second highest Imports (BoP, current US$) of 2006?
Provide a short and direct response. 7.43e+11. What is the difference between the highest and the second highest Imports (BoP, current US$) in 2007?
Offer a terse response. 8.82e+11. What is the difference between the highest and the second highest Imports (BoP, current US$) of 2008?
Your answer should be very brief. 1.01e+12. What is the difference between the highest and the lowest Imports (BoP, current US$) in 2005?
Ensure brevity in your answer.  9.29e+11. What is the difference between the highest and the lowest Imports (BoP, current US$) in 2006?
Your answer should be compact. 1.07e+12. What is the difference between the highest and the lowest Imports (BoP, current US$) of 2007?
Give a very brief answer. 1.25e+12. What is the difference between the highest and the lowest Imports (BoP, current US$) in 2008?
Offer a very short reply. 1.41e+12. 